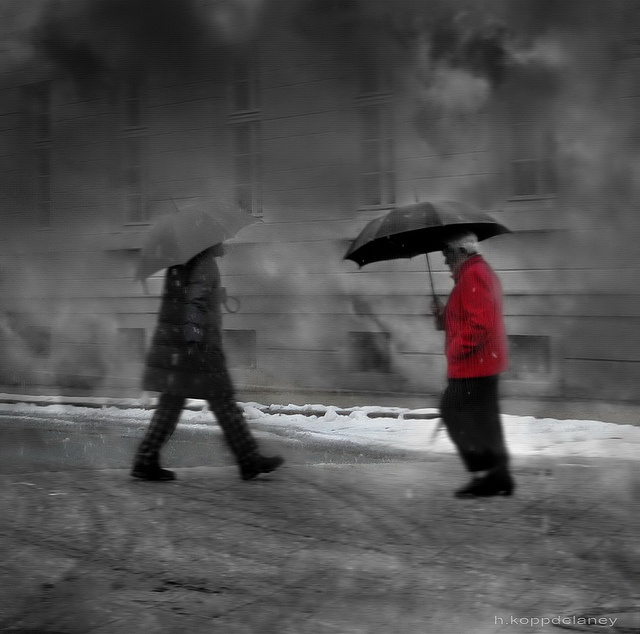Describe the objects in this image and their specific colors. I can see people in gray, black, maroon, and brown tones, people in gray and black tones, umbrella in gray and black tones, and umbrella in gray and black tones in this image. 